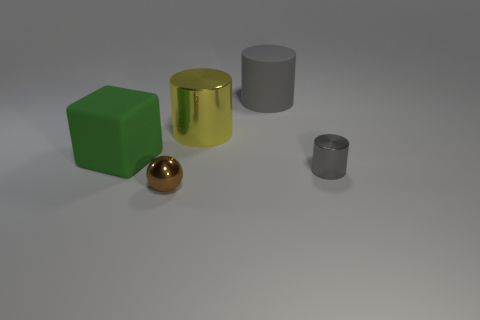Add 3 big gray matte cylinders. How many objects exist? 8 Subtract all green spheres. How many gray cylinders are left? 2 Subtract all large metallic cylinders. How many cylinders are left? 2 Subtract all gray cylinders. How many cylinders are left? 1 Subtract 0 yellow blocks. How many objects are left? 5 Subtract all balls. How many objects are left? 4 Subtract all purple cylinders. Subtract all green blocks. How many cylinders are left? 3 Subtract all large matte blocks. Subtract all big cylinders. How many objects are left? 2 Add 4 matte things. How many matte things are left? 6 Add 2 rubber blocks. How many rubber blocks exist? 3 